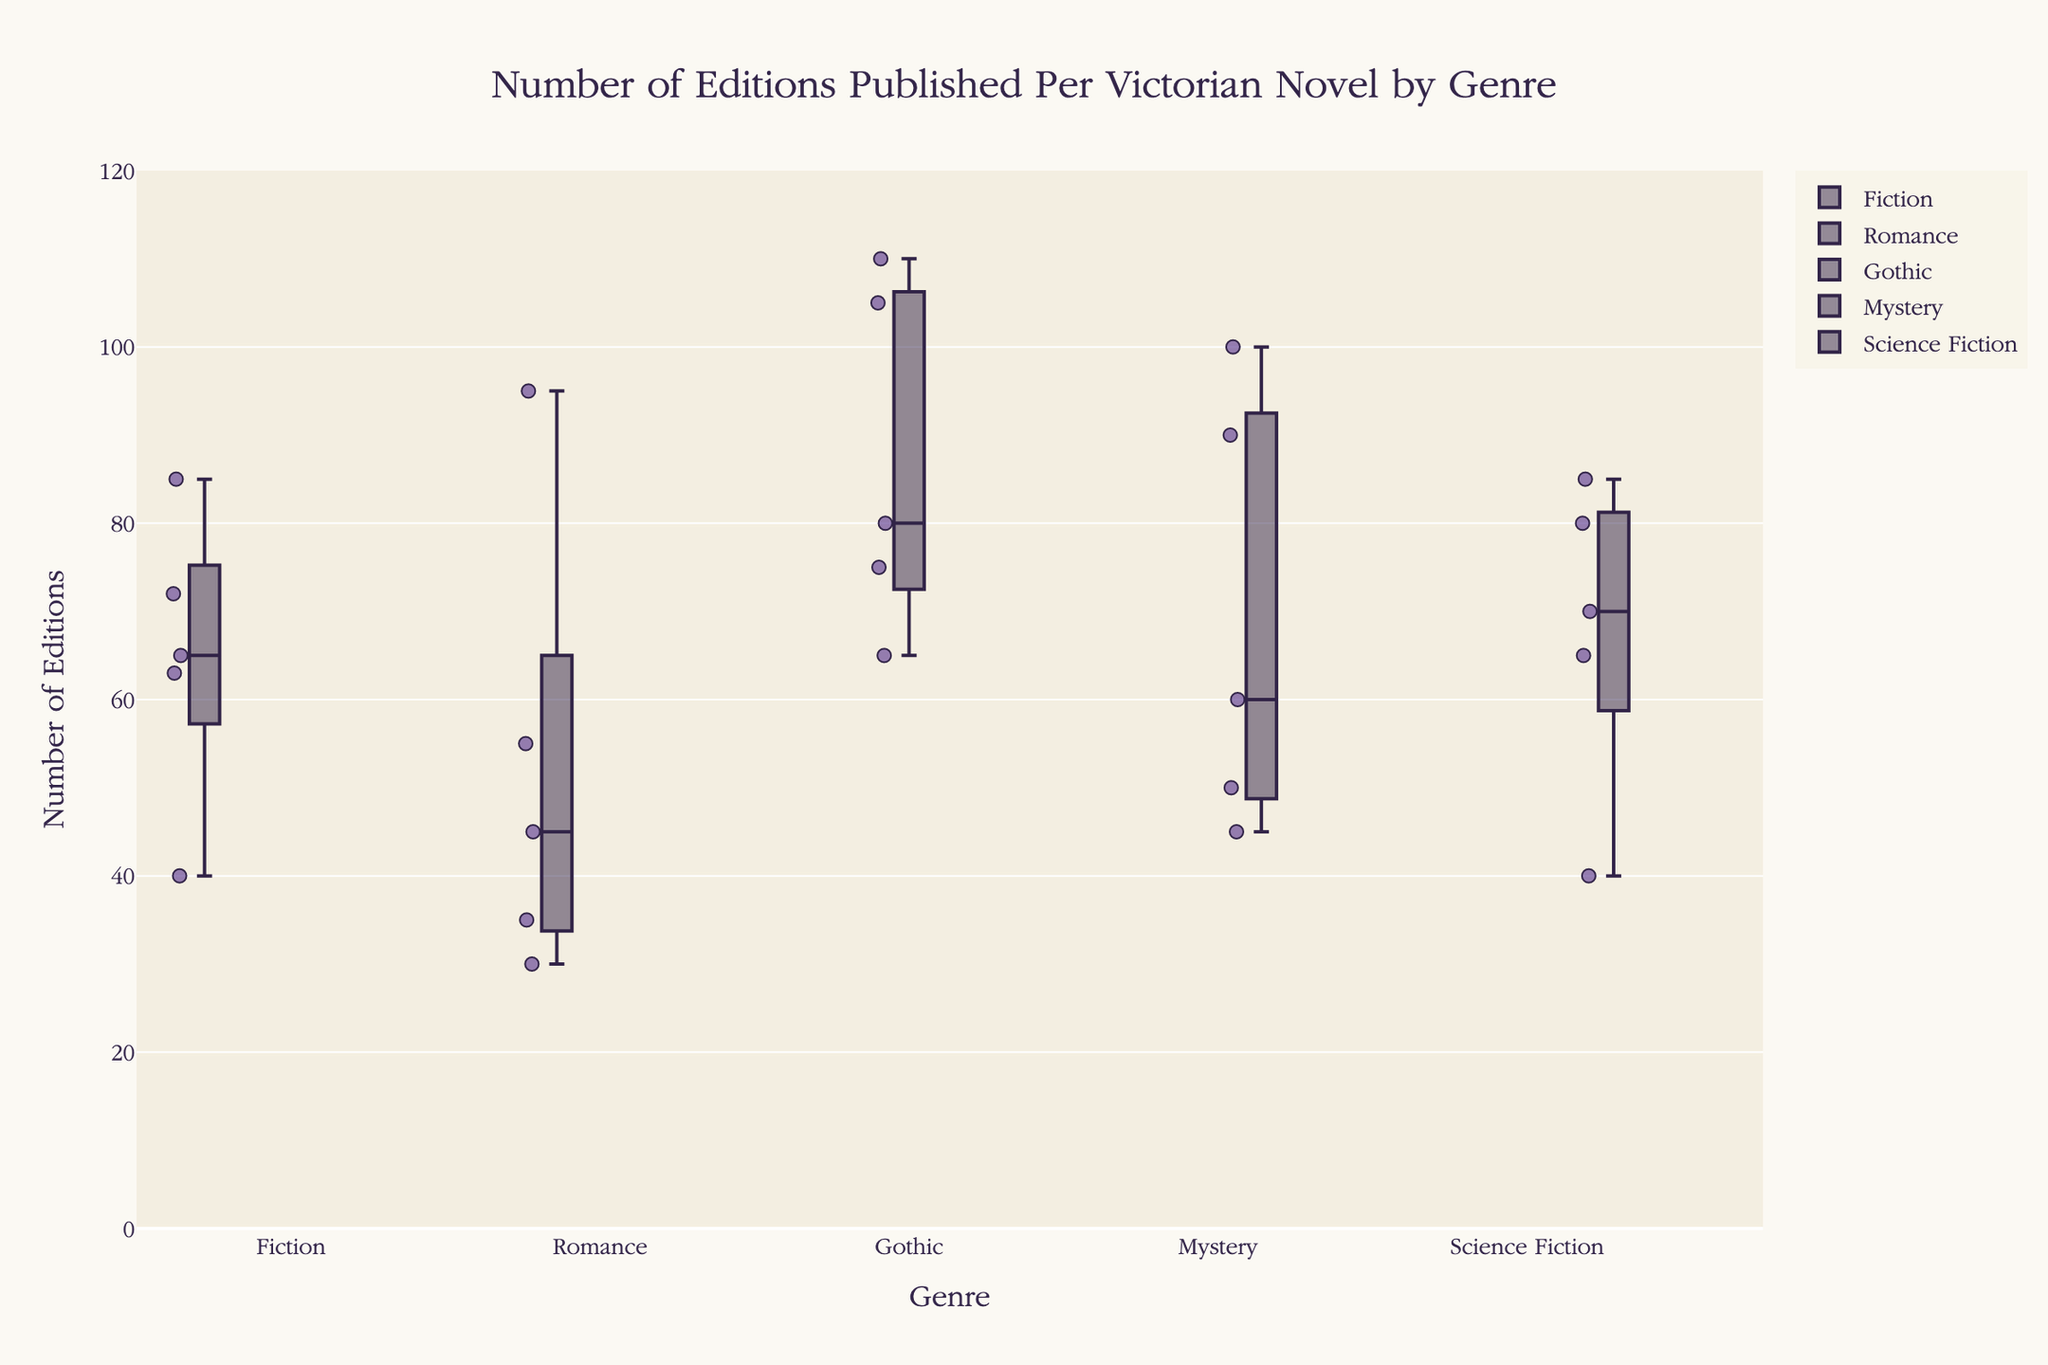What is the title of the box plot? The title is usually displayed at the top of the plot, summarizing the main focus of the data visualization.
Answer: Number of Editions Published Per Victorian Novel by Genre What is the range of the y-axis in this box plot? The range of the y-axis is specified in the layout settings of the plot, typically from the minimum to the maximum value visualized.
Answer: 0 to 120 How many genres are displayed in the box plot? Each genre corresponds to a unique category on the x-axis. Count the unique labels on the x-axis to find the number of genres.
Answer: Five Which genre has the highest median number of editions? The median for each genre can be identified by finding the line inside each box plot. The genre with the highest median is the one with the highest line.
Answer: Gothic What is the minimum number of editions in the Romance genre? The minimum value in a box plot is represented by the lower whisker. Locate the lower whisker for the Romance genre to find this value.
Answer: 30 Which genre has the greatest spread (range) of editions published? The spread or range is determined by the distance between the upper and lower whiskers. Find the genre with the greatest distance between these whiskers.
Answer: Gothic Compare the interquartile ranges (IQRs) of Gothic and Mystery genres. Which one is larger? The IQR is the length of the box (between the lower quartile and the upper quartile). Compare the sizes of the boxes for Gothic and Mystery genres.
Answer: Gothic Is the number of editions for the novel "Journey to the Center of the Earth" above or below the median for the Science Fiction genre? Find the median for Science Fiction by the line inside the box. Check if "Journey to the Center of the Earth" (65 editions) is above or below this line.
Answer: Below Which has more variability in the number of editions: Fiction or Science Fiction? Variability can be assessed by the length of the whiskers and the size of the boxes. Compare these for Fiction and Science Fiction genres.
Answer: Fiction Does any genre show any noticeable outliers? If so, which genre? Outliers in a box plot are typically marked as individual points outside the whiskers. Identify if any genre has such points.
Answer: No 